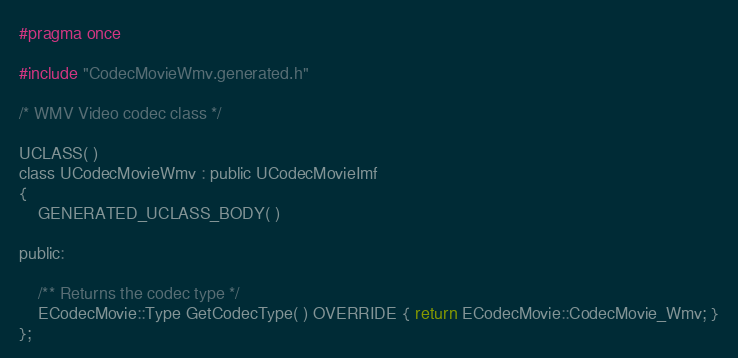<code> <loc_0><loc_0><loc_500><loc_500><_C_>
#pragma once

#include "CodecMovieWmv.generated.h"

/* WMV Video codec class */

UCLASS( )
class UCodecMovieWmv : public UCodecMovieImf
{
	GENERATED_UCLASS_BODY( )

public:

	/** Returns the codec type */
	ECodecMovie::Type GetCodecType( ) OVERRIDE { return ECodecMovie::CodecMovie_Wmv; }
};
</code> 